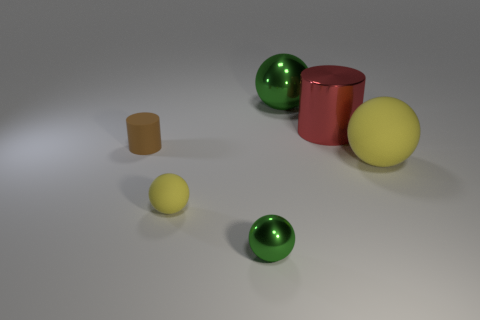What material is the green sphere that is the same size as the metal cylinder?
Your answer should be compact. Metal. There is a yellow rubber thing that is to the right of the shiny sphere on the right side of the green metal thing in front of the big green sphere; what size is it?
Offer a very short reply. Large. Does the cylinder on the right side of the tiny brown matte cylinder have the same color as the rubber ball that is on the right side of the tiny green metal sphere?
Your answer should be compact. No. How many yellow things are spheres or large matte objects?
Provide a short and direct response. 2. How many objects are the same size as the brown cylinder?
Your response must be concise. 2. Do the sphere behind the brown thing and the tiny brown object have the same material?
Give a very brief answer. No. Is there a matte ball on the right side of the yellow sphere on the right side of the small green ball?
Offer a terse response. No. There is a small yellow object that is the same shape as the large green metal object; what material is it?
Offer a very short reply. Rubber. Is the number of big matte objects right of the big rubber ball greater than the number of small green balls that are behind the rubber cylinder?
Keep it short and to the point. No. What is the shape of the large thing that is the same material as the big cylinder?
Make the answer very short. Sphere. 